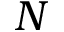Convert formula to latex. <formula><loc_0><loc_0><loc_500><loc_500>N</formula> 